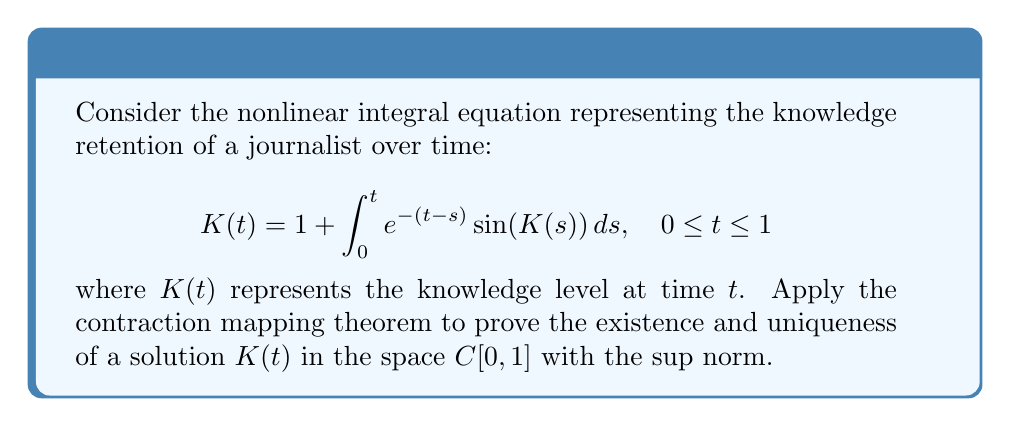Provide a solution to this math problem. 1. Define the operator $T$ on $C[0,1]$ by:
   $$T(K)(t) = 1 + \int_0^t e^{-(t-s)} \sin(K(s)) ds$$

2. Show that $T$ maps $C[0,1]$ into itself:
   For $K \in C[0,1]$, $T(K)$ is continuous on $[0,1]$.

3. Prove $T$ is a contraction:
   For $K_1, K_2 \in C[0,1]$,
   $$\begin{align}
   |T(K_1)(t) - T(K_2)(t)| &= \left|\int_0^t e^{-(t-s)} [\sin(K_1(s)) - \sin(K_2(s))] ds\right| \\
   &\leq \int_0^t e^{-(t-s)} |\sin(K_1(s)) - \sin(K_2(s))| ds \\
   &\leq \int_0^t e^{-(t-s)} |K_1(s) - K_2(s)| ds \\
   &\leq \|K_1 - K_2\|_\infty \int_0^t e^{-(t-s)} ds \\
   &= \|K_1 - K_2\|_\infty (1 - e^{-t}) \\
   &\leq (1 - e^{-1}) \|K_1 - K_2\|_\infty
   \end{align}$$

   Therefore, $\|T(K_1) - T(K_2)\|_\infty \leq (1 - e^{-1}) \|K_1 - K_2\|_\infty$

4. Since $1 - e^{-1} \approx 0.632 < 1$, $T$ is a contraction mapping.

5. By the contraction mapping theorem, $T$ has a unique fixed point in $C[0,1]$, which is the unique solution to the integral equation.
Answer: Unique solution exists in $C[0,1]$ 